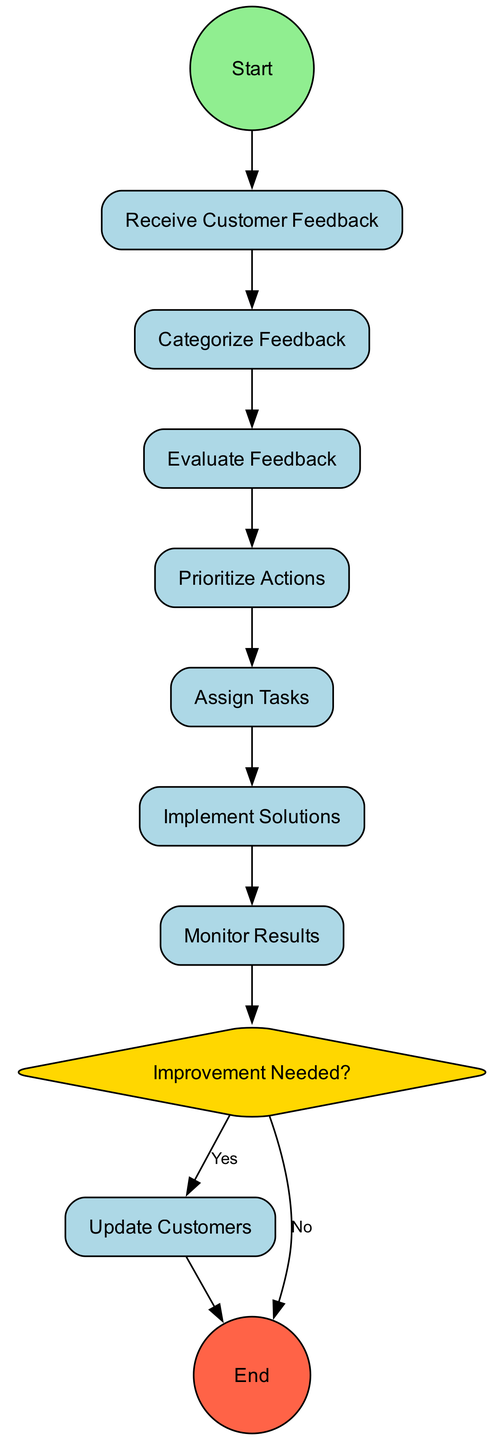What is the first activity in the workflow? The first activity is "Receive Customer Feedback", which is directly connected to the start node.
Answer: Receive Customer Feedback How many activities are there in the workflow? There are eight activities listed, each representing a step in the feedback processing workflow.
Answer: Eight What is the last activity before the decision point? The last activity before the decision point is "Evaluate Feedback", which is the second to last node in the flow.
Answer: Evaluate Feedback Is there a point where a decision is made? Yes, there is a decision point named "Improvement Needed?" which determines the next step based on feedback.
Answer: Yes What happens if "Improvement Needed?" is answered with 'No'? If "Improvement Needed?" is answered with 'No', the flow proceeds directly to the end node, skipping further actions related to feedback improvement.
Answer: End What are the two outcomes from the decision node? The two outcomes are "Yes" which leads to implementing solutions and "No" which leads to the end of the process.
Answer: Yes, No Which activity involves communication with customers? The activity that involves communication with customers is "Update Customers", which is the final step of the feedback processing workflow.
Answer: Update Customers Which activity comes after "Assign Tasks"? The activity that comes after "Assign Tasks" is "Implement Solutions", indicating the execution of assigned tasks.
Answer: Implement Solutions 